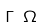<formula> <loc_0><loc_0><loc_500><loc_500>\Gamma \ \Omega</formula> 